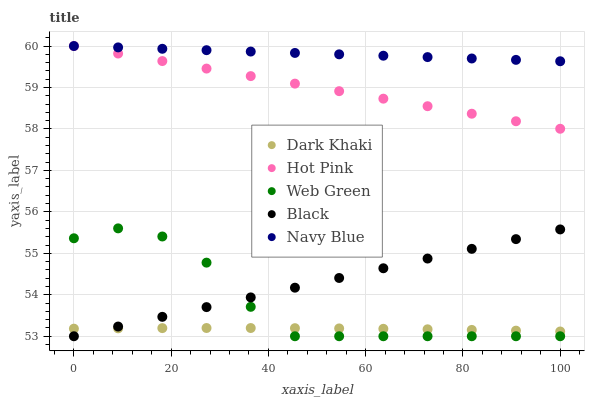Does Dark Khaki have the minimum area under the curve?
Answer yes or no. Yes. Does Navy Blue have the maximum area under the curve?
Answer yes or no. Yes. Does Hot Pink have the minimum area under the curve?
Answer yes or no. No. Does Hot Pink have the maximum area under the curve?
Answer yes or no. No. Is Hot Pink the smoothest?
Answer yes or no. Yes. Is Web Green the roughest?
Answer yes or no. Yes. Is Navy Blue the smoothest?
Answer yes or no. No. Is Navy Blue the roughest?
Answer yes or no. No. Does Black have the lowest value?
Answer yes or no. Yes. Does Hot Pink have the lowest value?
Answer yes or no. No. Does Hot Pink have the highest value?
Answer yes or no. Yes. Does Black have the highest value?
Answer yes or no. No. Is Black less than Hot Pink?
Answer yes or no. Yes. Is Navy Blue greater than Web Green?
Answer yes or no. Yes. Does Black intersect Dark Khaki?
Answer yes or no. Yes. Is Black less than Dark Khaki?
Answer yes or no. No. Is Black greater than Dark Khaki?
Answer yes or no. No. Does Black intersect Hot Pink?
Answer yes or no. No. 